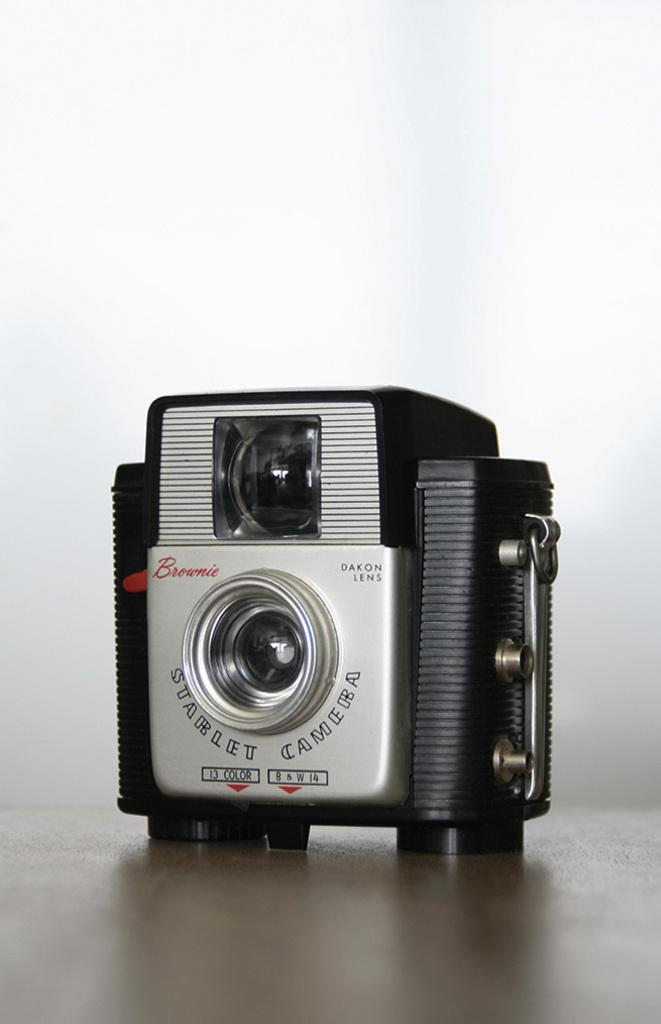What is the main object in the image? There is a camera in the image. Where is the camera located? The camera is on a surface. What type of trail can be seen in the image? There is no trail present in the image; it only features a camera on a surface. 